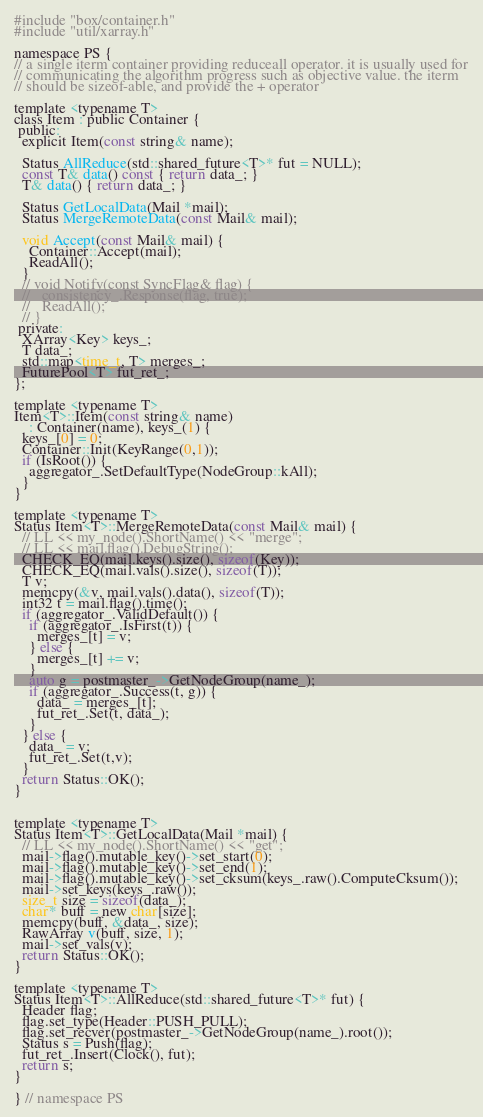<code> <loc_0><loc_0><loc_500><loc_500><_C_>
#include "box/container.h"
#include "util/xarray.h"

namespace PS {
// a single iterm container providing reduceall operator. it is usually used for
// communicating the algorithm progress such as objective value. the iterm
// should be sizeof-able, and provide the + operator

template <typename T>
class Item : public Container {
 public:
  explicit Item(const string& name);

  Status AllReduce(std::shared_future<T>* fut = NULL);
  const T& data() const { return data_; }
  T& data() { return data_; }

  Status GetLocalData(Mail *mail);
  Status MergeRemoteData(const Mail& mail);

  void Accept(const Mail& mail) {
    Container::Accept(mail);
    ReadAll();
  }
  // void Notify(const SyncFlag& flag) {
  //   consistency_.Response(flag, true);
  //   ReadAll();
  // }
 private:
  XArray<Key> keys_;
  T data_;
  std::map<time_t, T> merges_;
  FuturePool<T> fut_ret_;
};

template <typename T>
Item<T>::Item(const string& name)
    : Container(name), keys_(1) {
  keys_[0] = 0;
  Container::Init(KeyRange(0,1));
  if (IsRoot()) {
    aggregator_.SetDefaultType(NodeGroup::kAll);
  }
}

template <typename T>
Status Item<T>::MergeRemoteData(const Mail& mail) {
  // LL << my_node().ShortName() << "merge";
  // LL << mail.flag().DebugString();
  CHECK_EQ(mail.keys().size(), sizeof(Key));
  CHECK_EQ(mail.vals().size(), sizeof(T));
  T v;
  memcpy(&v, mail.vals().data(), sizeof(T));
  int32 t = mail.flag().time();
  if (aggregator_.ValidDefault()) {
    if (aggregator_.IsFirst(t)) {
      merges_[t] = v;
    } else {
      merges_[t] += v;
    }
    auto g = postmaster_->GetNodeGroup(name_);
    if (aggregator_.Success(t, g)) {
      data_ = merges_[t];
      fut_ret_.Set(t, data_);
    }
  } else {
    data_ = v;
    fut_ret_.Set(t,v);
  }
  return Status::OK();
}


template <typename T>
Status Item<T>::GetLocalData(Mail *mail) {
  // LL << my_node().ShortName() << "get";
  mail->flag().mutable_key()->set_start(0);
  mail->flag().mutable_key()->set_end(1);
  mail->flag().mutable_key()->set_cksum(keys_.raw().ComputeCksum());
  mail->set_keys(keys_.raw());
  size_t size = sizeof(data_);
  char* buff = new char[size];
  memcpy(buff, &data_, size);
  RawArray v(buff, size, 1);
  mail->set_vals(v);
  return Status::OK();
}

template <typename T>
Status Item<T>::AllReduce(std::shared_future<T>* fut) {
  Header flag;
  flag.set_type(Header::PUSH_PULL);
  flag.set_recver(postmaster_->GetNodeGroup(name_).root());
  Status s = Push(flag);
  fut_ret_.Insert(Clock(), fut);
  return s;
}

} // namespace PS
</code> 